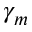<formula> <loc_0><loc_0><loc_500><loc_500>\gamma _ { m }</formula> 